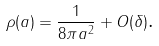<formula> <loc_0><loc_0><loc_500><loc_500>\rho ( a ) = \frac { 1 } { 8 \pi a ^ { 2 } } + O ( \delta ) \text {.}</formula> 